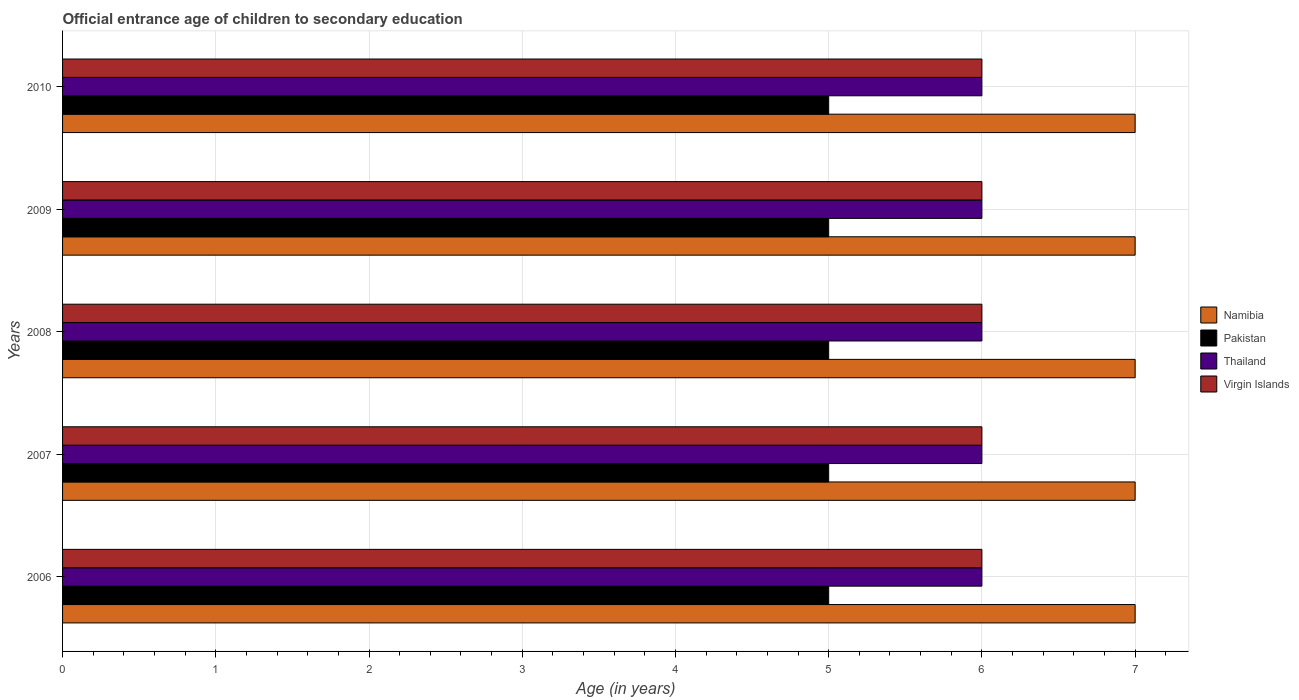Are the number of bars on each tick of the Y-axis equal?
Provide a succinct answer. Yes. What is the label of the 1st group of bars from the top?
Provide a succinct answer. 2010. Across all years, what is the maximum secondary school starting age of children in Namibia?
Ensure brevity in your answer.  7. Across all years, what is the minimum secondary school starting age of children in Thailand?
Your answer should be compact. 6. What is the total secondary school starting age of children in Namibia in the graph?
Offer a very short reply. 35. What is the difference between the secondary school starting age of children in Virgin Islands in 2009 and that in 2010?
Your response must be concise. 0. What is the difference between the secondary school starting age of children in Thailand in 2006 and the secondary school starting age of children in Namibia in 2007?
Keep it short and to the point. -1. In the year 2007, what is the difference between the secondary school starting age of children in Thailand and secondary school starting age of children in Namibia?
Your response must be concise. -1. Is the difference between the secondary school starting age of children in Thailand in 2007 and 2009 greater than the difference between the secondary school starting age of children in Namibia in 2007 and 2009?
Offer a very short reply. No. What is the difference between the highest and the second highest secondary school starting age of children in Virgin Islands?
Your answer should be compact. 0. Is it the case that in every year, the sum of the secondary school starting age of children in Thailand and secondary school starting age of children in Pakistan is greater than the sum of secondary school starting age of children in Virgin Islands and secondary school starting age of children in Namibia?
Give a very brief answer. No. What does the 4th bar from the bottom in 2007 represents?
Your answer should be compact. Virgin Islands. How many years are there in the graph?
Your answer should be compact. 5. Are the values on the major ticks of X-axis written in scientific E-notation?
Give a very brief answer. No. Does the graph contain any zero values?
Give a very brief answer. No. Does the graph contain grids?
Offer a very short reply. Yes. What is the title of the graph?
Provide a short and direct response. Official entrance age of children to secondary education. What is the label or title of the X-axis?
Offer a terse response. Age (in years). What is the Age (in years) of Virgin Islands in 2006?
Provide a short and direct response. 6. What is the Age (in years) in Namibia in 2007?
Provide a succinct answer. 7. What is the Age (in years) of Pakistan in 2008?
Offer a very short reply. 5. What is the Age (in years) of Thailand in 2008?
Provide a succinct answer. 6. What is the Age (in years) of Virgin Islands in 2008?
Give a very brief answer. 6. What is the Age (in years) in Namibia in 2009?
Your response must be concise. 7. What is the Age (in years) of Pakistan in 2009?
Provide a succinct answer. 5. What is the Age (in years) of Thailand in 2009?
Offer a very short reply. 6. What is the Age (in years) in Namibia in 2010?
Keep it short and to the point. 7. Across all years, what is the maximum Age (in years) in Thailand?
Your response must be concise. 6. Across all years, what is the minimum Age (in years) of Namibia?
Your answer should be very brief. 7. Across all years, what is the minimum Age (in years) in Virgin Islands?
Your response must be concise. 6. What is the total Age (in years) of Thailand in the graph?
Your answer should be very brief. 30. What is the total Age (in years) of Virgin Islands in the graph?
Your answer should be very brief. 30. What is the difference between the Age (in years) of Virgin Islands in 2006 and that in 2008?
Provide a short and direct response. 0. What is the difference between the Age (in years) of Namibia in 2006 and that in 2009?
Provide a succinct answer. 0. What is the difference between the Age (in years) in Pakistan in 2006 and that in 2009?
Your response must be concise. 0. What is the difference between the Age (in years) of Namibia in 2006 and that in 2010?
Provide a short and direct response. 0. What is the difference between the Age (in years) of Pakistan in 2006 and that in 2010?
Your answer should be very brief. 0. What is the difference between the Age (in years) in Thailand in 2006 and that in 2010?
Your answer should be very brief. 0. What is the difference between the Age (in years) in Namibia in 2007 and that in 2008?
Give a very brief answer. 0. What is the difference between the Age (in years) of Pakistan in 2007 and that in 2008?
Your response must be concise. 0. What is the difference between the Age (in years) of Thailand in 2007 and that in 2008?
Offer a terse response. 0. What is the difference between the Age (in years) of Namibia in 2007 and that in 2009?
Make the answer very short. 0. What is the difference between the Age (in years) of Virgin Islands in 2007 and that in 2010?
Offer a very short reply. 0. What is the difference between the Age (in years) in Namibia in 2008 and that in 2009?
Offer a terse response. 0. What is the difference between the Age (in years) of Pakistan in 2008 and that in 2009?
Ensure brevity in your answer.  0. What is the difference between the Age (in years) in Virgin Islands in 2008 and that in 2009?
Your response must be concise. 0. What is the difference between the Age (in years) in Virgin Islands in 2008 and that in 2010?
Your response must be concise. 0. What is the difference between the Age (in years) in Namibia in 2009 and that in 2010?
Your response must be concise. 0. What is the difference between the Age (in years) in Virgin Islands in 2009 and that in 2010?
Make the answer very short. 0. What is the difference between the Age (in years) in Namibia in 2006 and the Age (in years) in Thailand in 2007?
Give a very brief answer. 1. What is the difference between the Age (in years) of Thailand in 2006 and the Age (in years) of Virgin Islands in 2007?
Provide a short and direct response. 0. What is the difference between the Age (in years) of Namibia in 2006 and the Age (in years) of Pakistan in 2008?
Offer a very short reply. 2. What is the difference between the Age (in years) in Namibia in 2006 and the Age (in years) in Thailand in 2008?
Your response must be concise. 1. What is the difference between the Age (in years) of Pakistan in 2006 and the Age (in years) of Thailand in 2008?
Your answer should be compact. -1. What is the difference between the Age (in years) of Thailand in 2006 and the Age (in years) of Virgin Islands in 2008?
Your answer should be compact. 0. What is the difference between the Age (in years) of Namibia in 2006 and the Age (in years) of Thailand in 2009?
Your response must be concise. 1. What is the difference between the Age (in years) of Namibia in 2006 and the Age (in years) of Virgin Islands in 2009?
Ensure brevity in your answer.  1. What is the difference between the Age (in years) in Pakistan in 2006 and the Age (in years) in Virgin Islands in 2009?
Make the answer very short. -1. What is the difference between the Age (in years) of Thailand in 2006 and the Age (in years) of Virgin Islands in 2009?
Ensure brevity in your answer.  0. What is the difference between the Age (in years) in Pakistan in 2006 and the Age (in years) in Thailand in 2010?
Keep it short and to the point. -1. What is the difference between the Age (in years) of Pakistan in 2006 and the Age (in years) of Virgin Islands in 2010?
Offer a terse response. -1. What is the difference between the Age (in years) in Namibia in 2007 and the Age (in years) in Pakistan in 2008?
Ensure brevity in your answer.  2. What is the difference between the Age (in years) in Namibia in 2007 and the Age (in years) in Thailand in 2008?
Ensure brevity in your answer.  1. What is the difference between the Age (in years) of Thailand in 2007 and the Age (in years) of Virgin Islands in 2008?
Make the answer very short. 0. What is the difference between the Age (in years) of Namibia in 2007 and the Age (in years) of Thailand in 2009?
Your answer should be very brief. 1. What is the difference between the Age (in years) of Pakistan in 2007 and the Age (in years) of Virgin Islands in 2009?
Ensure brevity in your answer.  -1. What is the difference between the Age (in years) of Namibia in 2007 and the Age (in years) of Pakistan in 2010?
Keep it short and to the point. 2. What is the difference between the Age (in years) in Namibia in 2007 and the Age (in years) in Thailand in 2010?
Your answer should be compact. 1. What is the difference between the Age (in years) in Namibia in 2007 and the Age (in years) in Virgin Islands in 2010?
Ensure brevity in your answer.  1. What is the difference between the Age (in years) in Pakistan in 2007 and the Age (in years) in Thailand in 2010?
Your response must be concise. -1. What is the difference between the Age (in years) in Pakistan in 2007 and the Age (in years) in Virgin Islands in 2010?
Provide a succinct answer. -1. What is the difference between the Age (in years) in Thailand in 2007 and the Age (in years) in Virgin Islands in 2010?
Provide a succinct answer. 0. What is the difference between the Age (in years) in Namibia in 2008 and the Age (in years) in Pakistan in 2009?
Make the answer very short. 2. What is the difference between the Age (in years) of Namibia in 2008 and the Age (in years) of Thailand in 2009?
Keep it short and to the point. 1. What is the difference between the Age (in years) of Namibia in 2008 and the Age (in years) of Pakistan in 2010?
Keep it short and to the point. 2. What is the difference between the Age (in years) of Pakistan in 2008 and the Age (in years) of Virgin Islands in 2010?
Ensure brevity in your answer.  -1. What is the difference between the Age (in years) of Namibia in 2009 and the Age (in years) of Virgin Islands in 2010?
Give a very brief answer. 1. What is the difference between the Age (in years) in Pakistan in 2009 and the Age (in years) in Thailand in 2010?
Your response must be concise. -1. What is the difference between the Age (in years) of Pakistan in 2009 and the Age (in years) of Virgin Islands in 2010?
Make the answer very short. -1. What is the difference between the Age (in years) of Thailand in 2009 and the Age (in years) of Virgin Islands in 2010?
Offer a terse response. 0. What is the average Age (in years) of Pakistan per year?
Provide a short and direct response. 5. What is the average Age (in years) of Thailand per year?
Make the answer very short. 6. What is the average Age (in years) of Virgin Islands per year?
Your answer should be very brief. 6. In the year 2006, what is the difference between the Age (in years) in Namibia and Age (in years) in Pakistan?
Your answer should be very brief. 2. In the year 2006, what is the difference between the Age (in years) of Namibia and Age (in years) of Thailand?
Your answer should be very brief. 1. In the year 2006, what is the difference between the Age (in years) in Namibia and Age (in years) in Virgin Islands?
Offer a terse response. 1. In the year 2006, what is the difference between the Age (in years) in Pakistan and Age (in years) in Thailand?
Offer a very short reply. -1. In the year 2006, what is the difference between the Age (in years) in Pakistan and Age (in years) in Virgin Islands?
Keep it short and to the point. -1. In the year 2007, what is the difference between the Age (in years) in Namibia and Age (in years) in Pakistan?
Provide a short and direct response. 2. In the year 2008, what is the difference between the Age (in years) in Namibia and Age (in years) in Pakistan?
Offer a very short reply. 2. In the year 2008, what is the difference between the Age (in years) in Namibia and Age (in years) in Virgin Islands?
Ensure brevity in your answer.  1. In the year 2008, what is the difference between the Age (in years) of Thailand and Age (in years) of Virgin Islands?
Provide a succinct answer. 0. In the year 2009, what is the difference between the Age (in years) in Namibia and Age (in years) in Pakistan?
Keep it short and to the point. 2. In the year 2009, what is the difference between the Age (in years) in Namibia and Age (in years) in Virgin Islands?
Provide a short and direct response. 1. In the year 2009, what is the difference between the Age (in years) of Pakistan and Age (in years) of Thailand?
Your response must be concise. -1. In the year 2009, what is the difference between the Age (in years) of Thailand and Age (in years) of Virgin Islands?
Give a very brief answer. 0. In the year 2010, what is the difference between the Age (in years) in Namibia and Age (in years) in Pakistan?
Offer a terse response. 2. In the year 2010, what is the difference between the Age (in years) of Namibia and Age (in years) of Thailand?
Your answer should be very brief. 1. What is the ratio of the Age (in years) of Namibia in 2006 to that in 2007?
Offer a very short reply. 1. What is the ratio of the Age (in years) in Pakistan in 2006 to that in 2007?
Your answer should be compact. 1. What is the ratio of the Age (in years) of Pakistan in 2006 to that in 2008?
Offer a terse response. 1. What is the ratio of the Age (in years) of Thailand in 2006 to that in 2008?
Offer a terse response. 1. What is the ratio of the Age (in years) of Namibia in 2006 to that in 2009?
Offer a very short reply. 1. What is the ratio of the Age (in years) in Pakistan in 2006 to that in 2009?
Provide a short and direct response. 1. What is the ratio of the Age (in years) of Namibia in 2006 to that in 2010?
Offer a very short reply. 1. What is the ratio of the Age (in years) in Thailand in 2006 to that in 2010?
Provide a short and direct response. 1. What is the ratio of the Age (in years) of Virgin Islands in 2006 to that in 2010?
Offer a very short reply. 1. What is the ratio of the Age (in years) of Pakistan in 2007 to that in 2008?
Offer a terse response. 1. What is the ratio of the Age (in years) in Thailand in 2007 to that in 2008?
Your answer should be very brief. 1. What is the ratio of the Age (in years) of Namibia in 2007 to that in 2009?
Your answer should be compact. 1. What is the ratio of the Age (in years) in Pakistan in 2007 to that in 2010?
Provide a short and direct response. 1. What is the ratio of the Age (in years) in Thailand in 2007 to that in 2010?
Provide a succinct answer. 1. What is the ratio of the Age (in years) of Virgin Islands in 2008 to that in 2009?
Give a very brief answer. 1. What is the ratio of the Age (in years) of Namibia in 2008 to that in 2010?
Ensure brevity in your answer.  1. What is the ratio of the Age (in years) of Pakistan in 2008 to that in 2010?
Provide a short and direct response. 1. What is the ratio of the Age (in years) in Thailand in 2008 to that in 2010?
Provide a short and direct response. 1. What is the ratio of the Age (in years) in Virgin Islands in 2008 to that in 2010?
Make the answer very short. 1. What is the ratio of the Age (in years) in Pakistan in 2009 to that in 2010?
Ensure brevity in your answer.  1. What is the ratio of the Age (in years) of Thailand in 2009 to that in 2010?
Your response must be concise. 1. What is the ratio of the Age (in years) of Virgin Islands in 2009 to that in 2010?
Provide a short and direct response. 1. What is the difference between the highest and the second highest Age (in years) of Namibia?
Provide a succinct answer. 0. What is the difference between the highest and the second highest Age (in years) in Virgin Islands?
Your answer should be compact. 0. What is the difference between the highest and the lowest Age (in years) in Pakistan?
Give a very brief answer. 0. What is the difference between the highest and the lowest Age (in years) in Virgin Islands?
Make the answer very short. 0. 